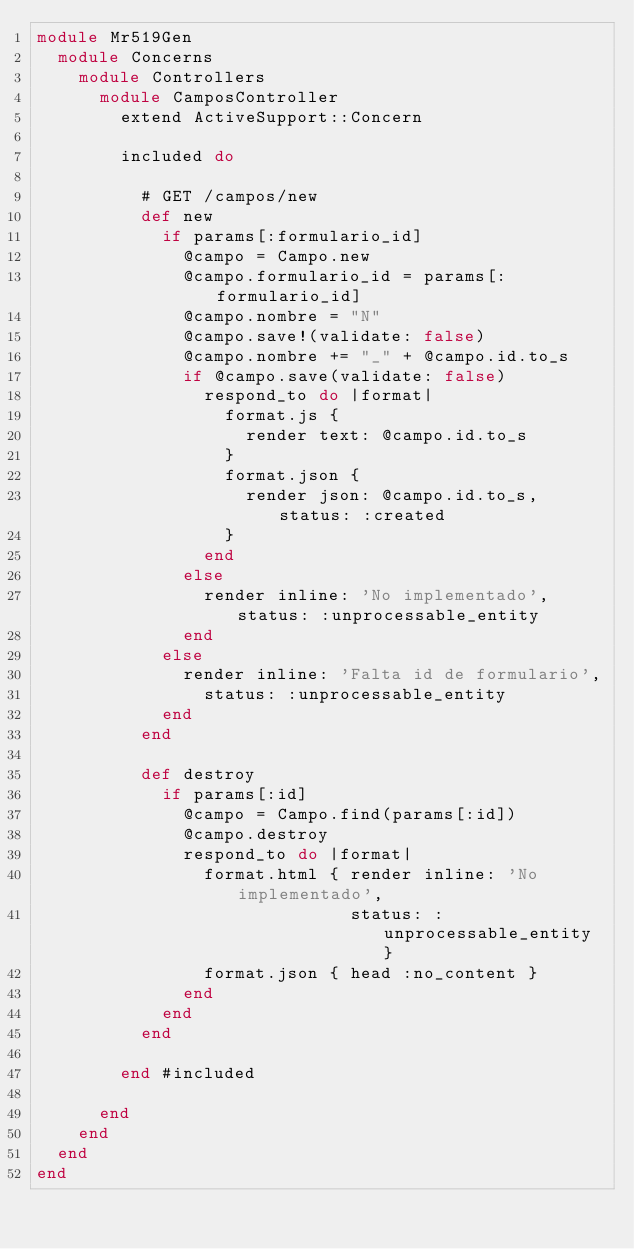Convert code to text. <code><loc_0><loc_0><loc_500><loc_500><_Ruby_>module Mr519Gen
  module Concerns
    module Controllers
      module CamposController
        extend ActiveSupport::Concern

        included do

          # GET /campos/new
          def new
            if params[:formulario_id]
              @campo = Campo.new
              @campo.formulario_id = params[:formulario_id]
              @campo.nombre = "N"
              @campo.save!(validate: false)
              @campo.nombre += "_" + @campo.id.to_s
              if @campo.save(validate: false)
                respond_to do |format|
                  format.js { 
                    render text: @campo.id.to_s 
                  }
                  format.json { 
                    render json: @campo.id.to_s, status: :created 
                  }
                end
              else
                render inline: 'No implementado', status: :unprocessable_entity 
              end
            else
              render inline: 'Falta id de formulario', 
                status: :unprocessable_entity 
            end
          end

          def destroy
            if params[:id]
              @campo = Campo.find(params[:id])
              @campo.destroy
              respond_to do |format|
                format.html { render inline: 'No implementado', 
                              status: :unprocessable_entity }
                format.json { head :no_content }
              end
            end
          end

        end #included

      end
    end
  end
end

</code> 